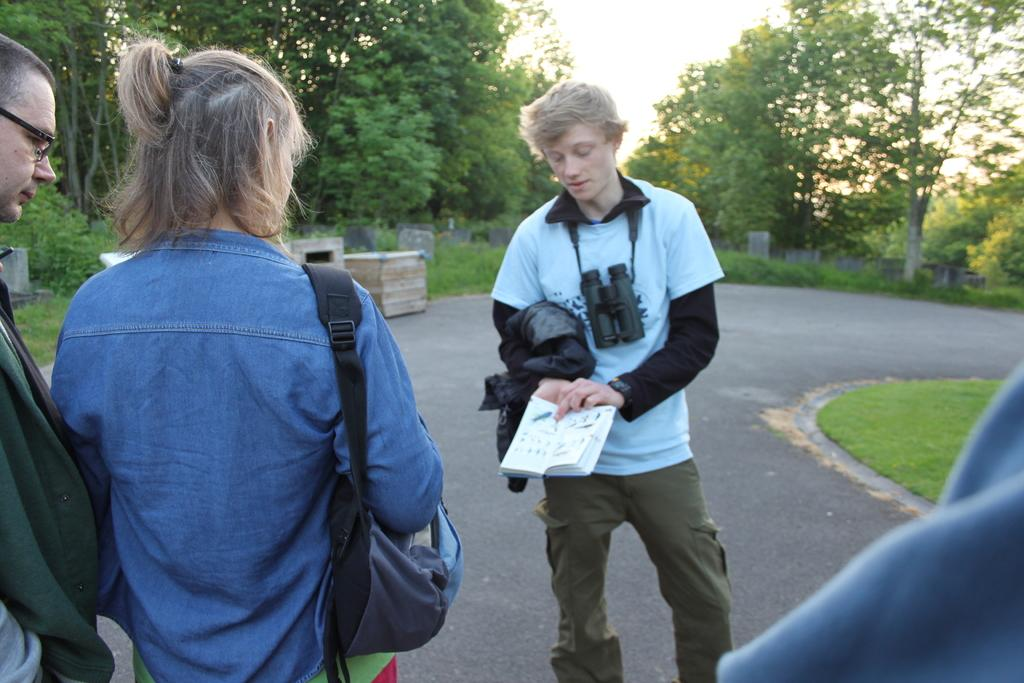What are the people in the image doing? The people in the image are standing on the road. Can you describe any specific accessory one of the people is wearing? One person is wearing binoculars around their neck. What can be seen in the background of the image? There are trees, grave stones, grass, and the sky visible in the background of the image. What type of thread is being used to guide the people in the image? There is no thread present in the image, and therefore no such guiding mechanism can be observed. 